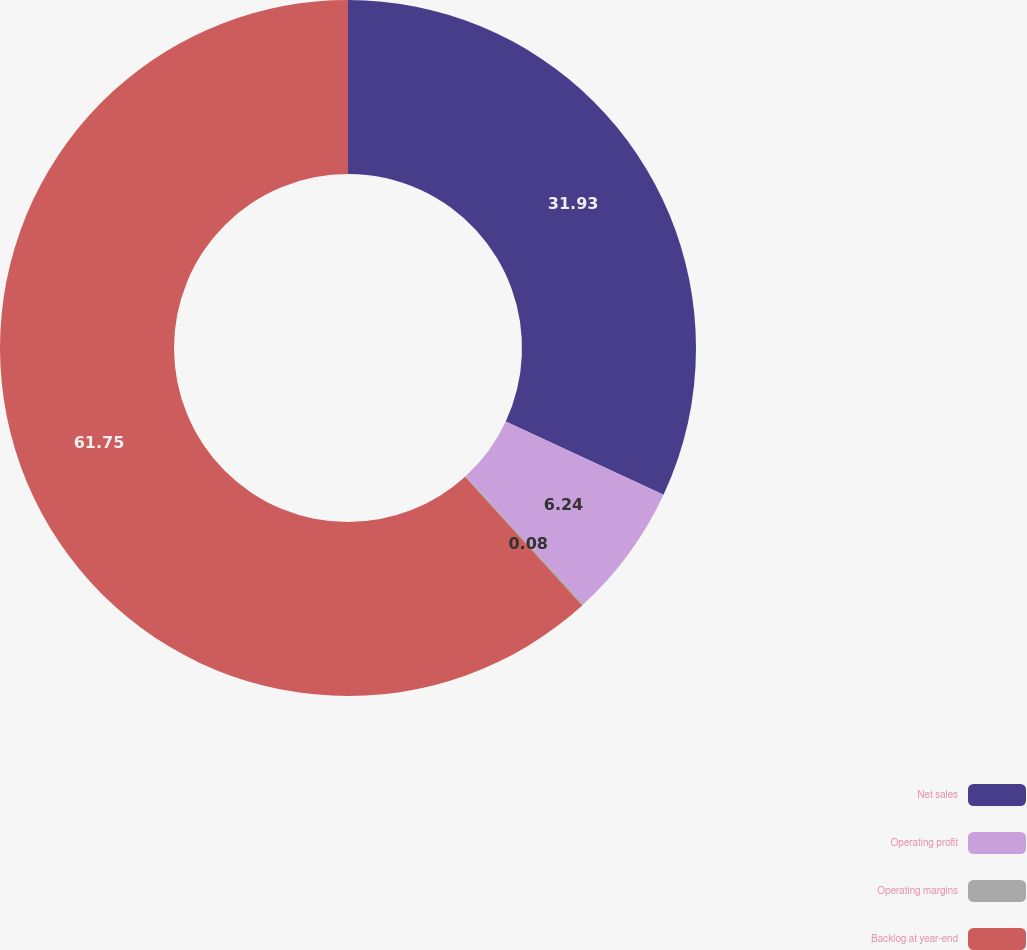Convert chart to OTSL. <chart><loc_0><loc_0><loc_500><loc_500><pie_chart><fcel>Net sales<fcel>Operating profit<fcel>Operating margins<fcel>Backlog at year-end<nl><fcel>31.93%<fcel>6.24%<fcel>0.08%<fcel>61.75%<nl></chart> 